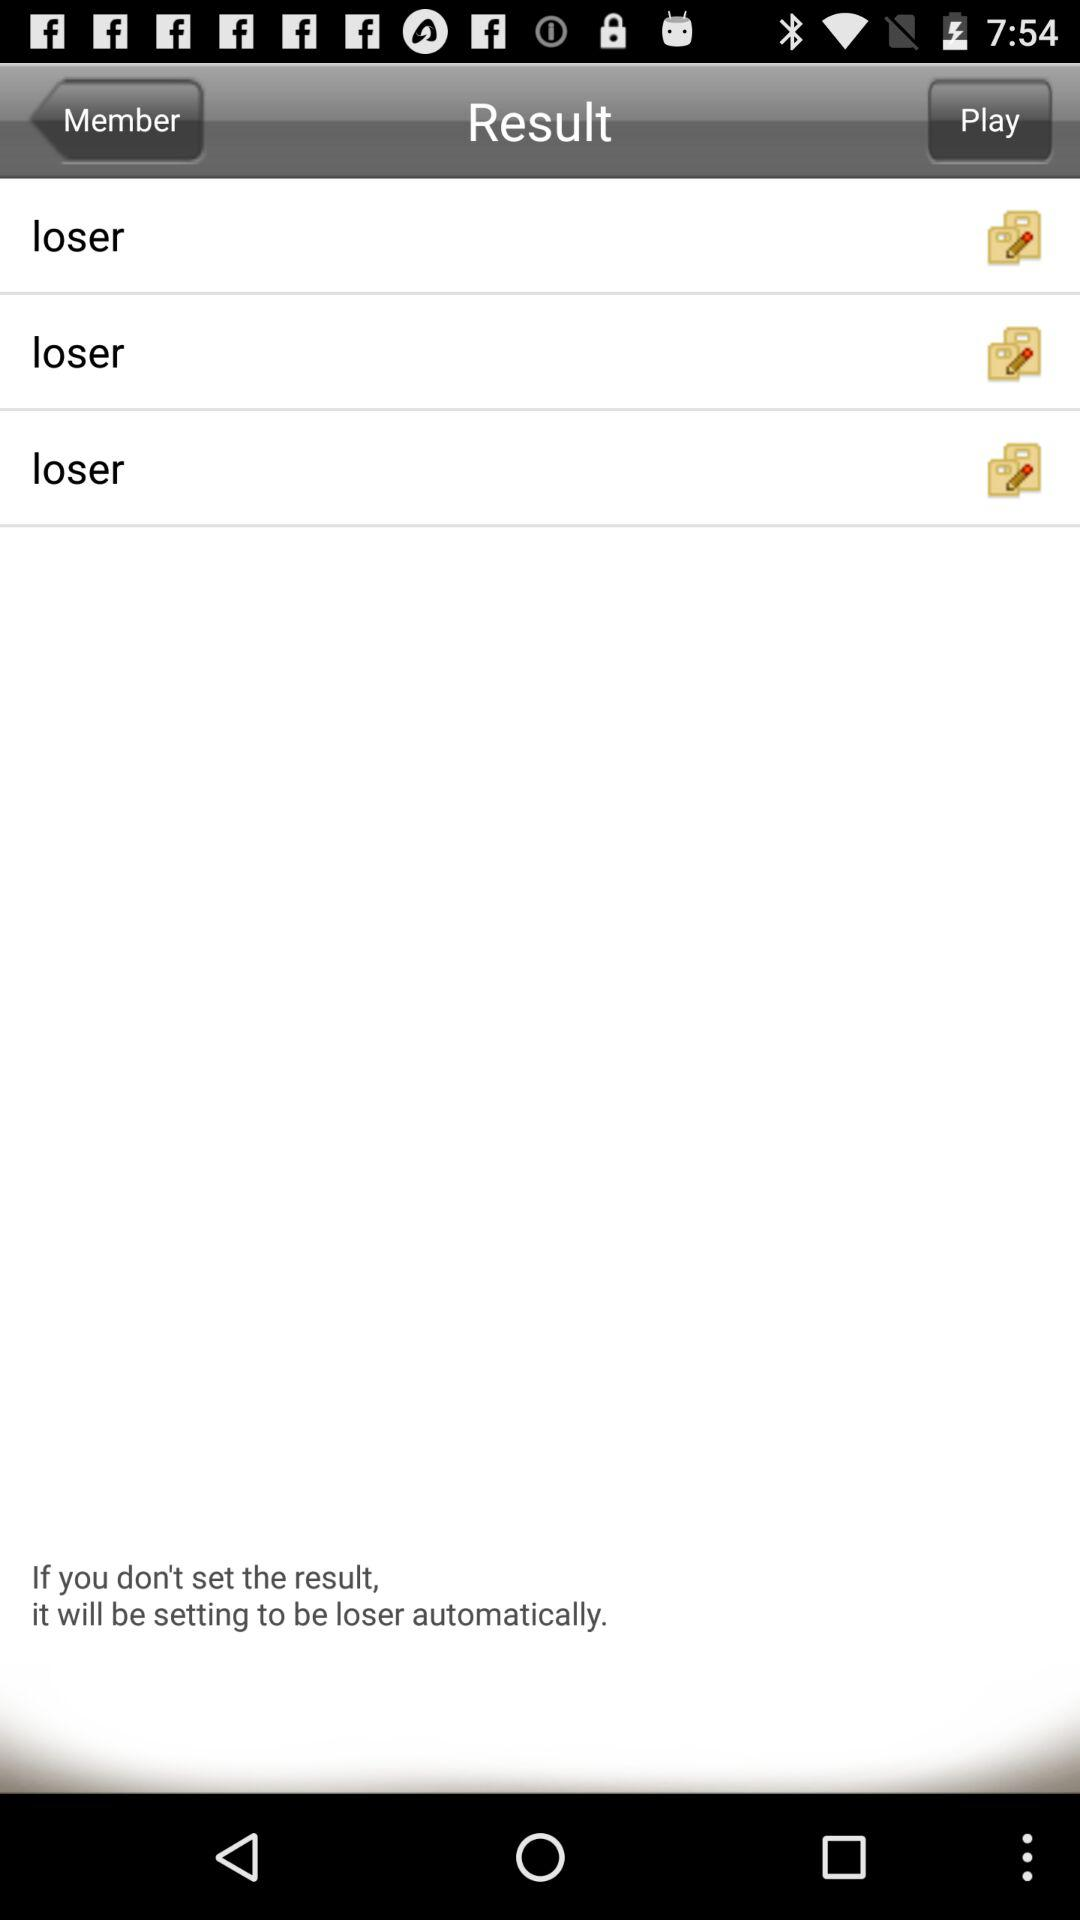How many loser results are there?
Answer the question using a single word or phrase. 3 